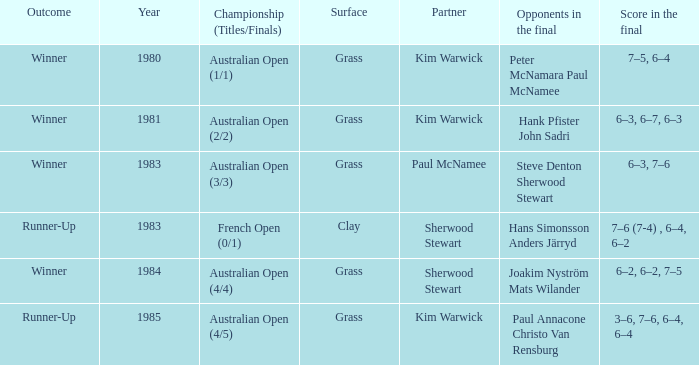In 1981, what competition was played? Australian Open (2/2). 